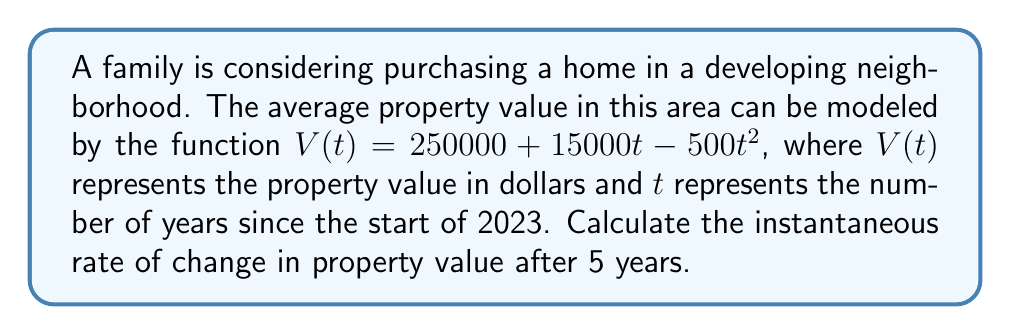Can you answer this question? To find the instantaneous rate of change in property value after 5 years, we need to calculate the derivative of the given function $V(t)$ and evaluate it at $t=5$.

1. Given function: $V(t) = 250000 + 15000t - 500t^2$

2. Calculate the derivative:
   $$\frac{dV}{dt} = 15000 - 1000t$$

3. Evaluate the derivative at $t=5$:
   $$\frac{dV}{dt}\Big|_{t=5} = 15000 - 1000(5)$$
   $$= 15000 - 5000$$
   $$= 10000$$

The instantaneous rate of change is $10000 dollars per year after 5 years.

This positive rate indicates that property values are still increasing, but at a slower rate than initially. This information is valuable for a first-time homebuyer, as it suggests that purchasing a property in this area could be a good investment, with the potential for appreciation over time.
Answer: $10000 dollars per year 